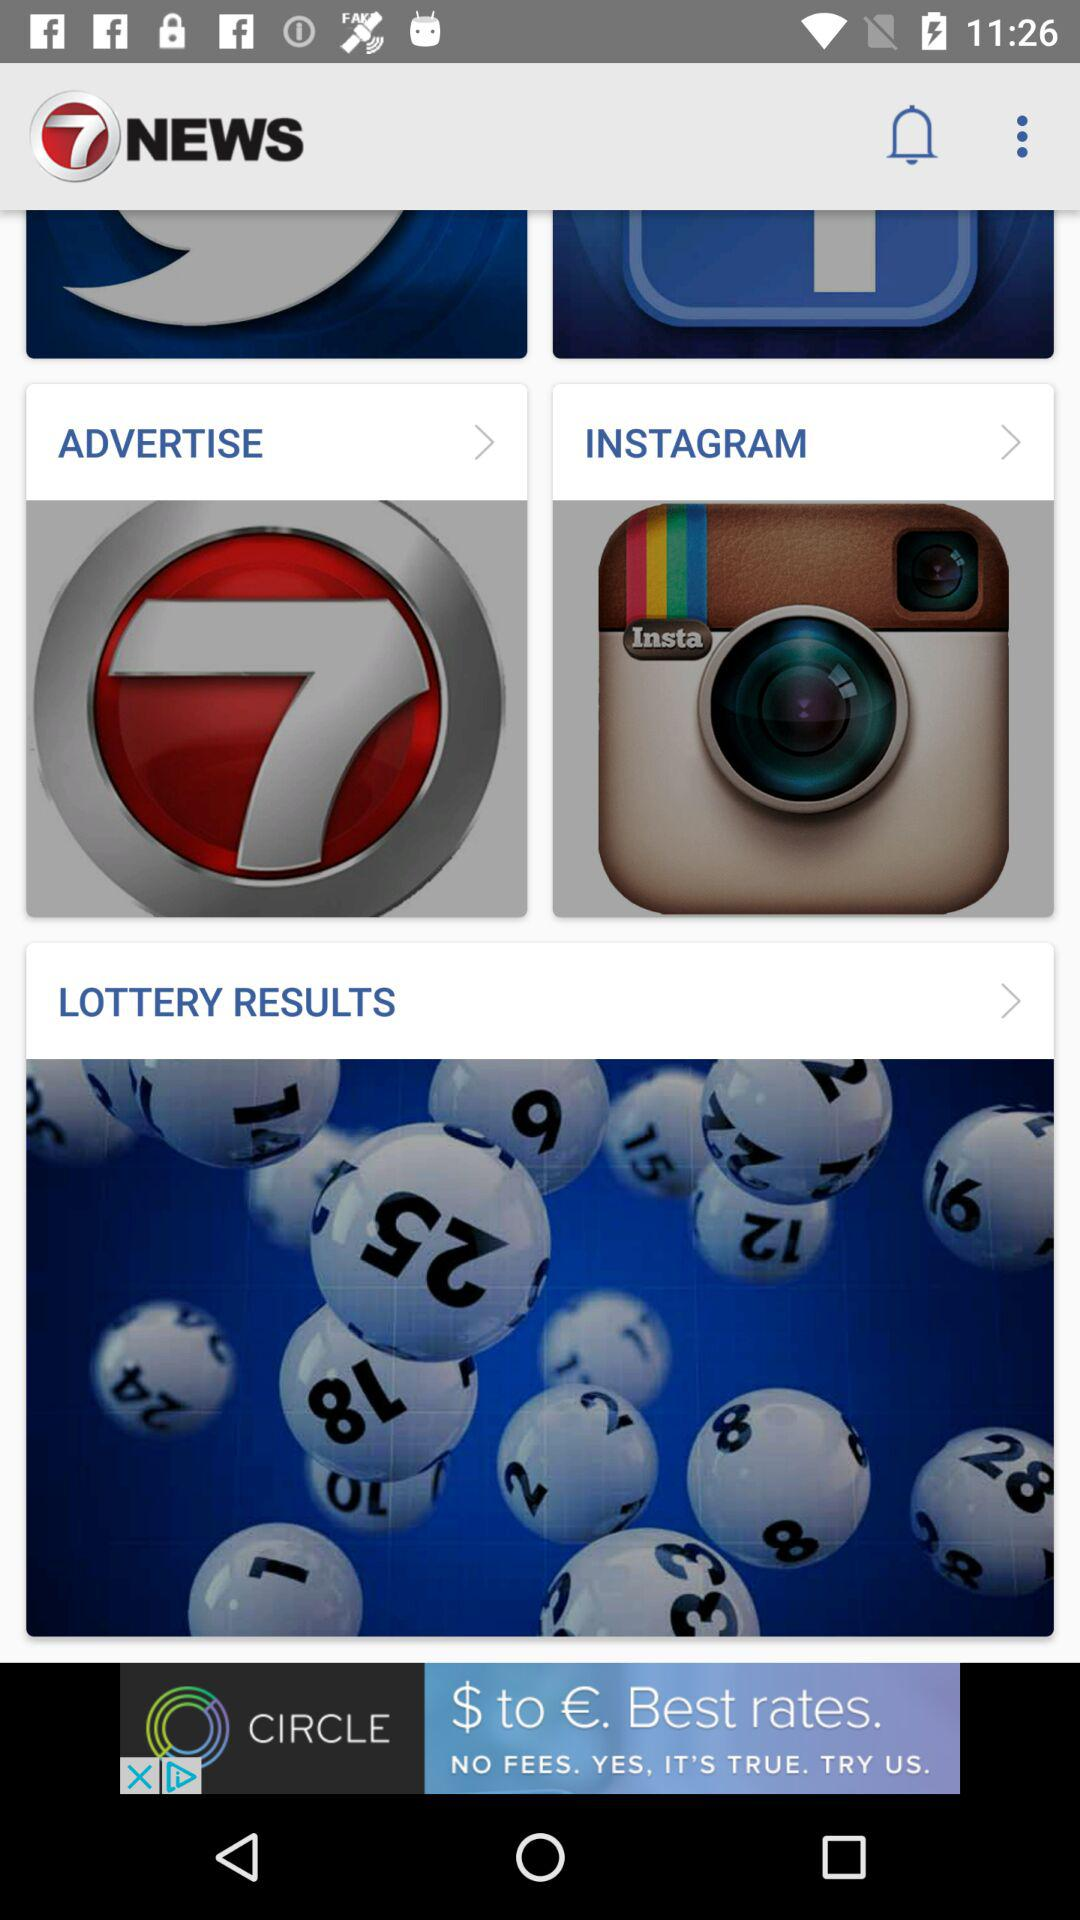What is the name of the application? The name of the application is "7NEWS". 